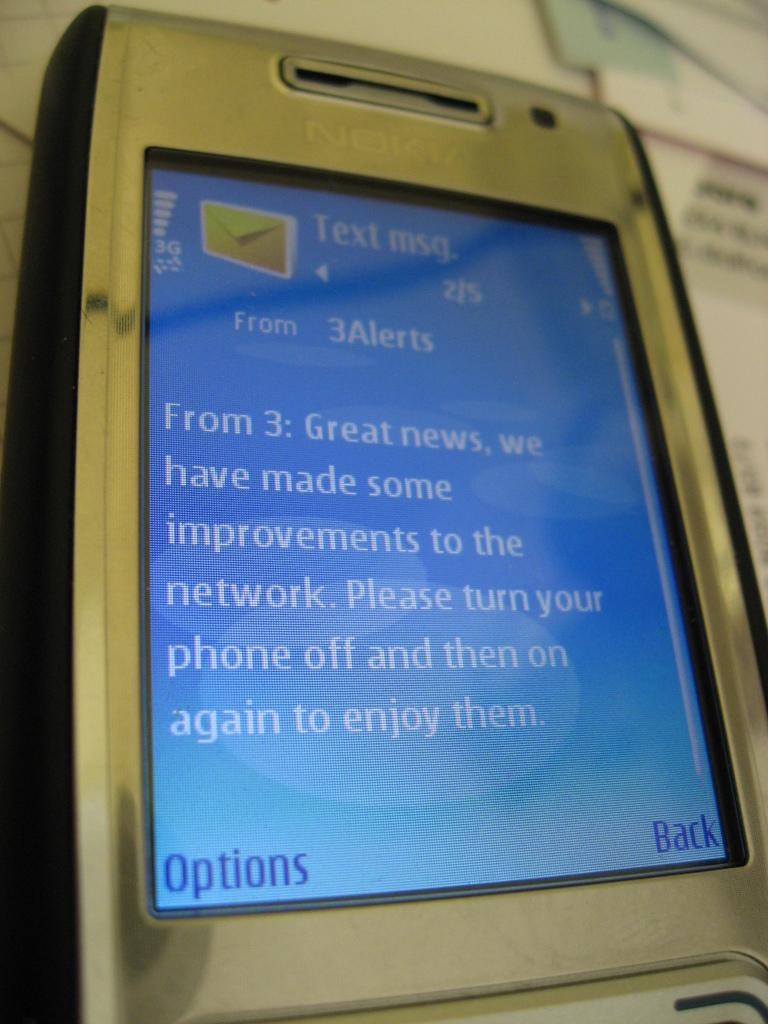<image>
Summarize the visual content of the image. An old cell phone shows a text that starts with from 3; great news 